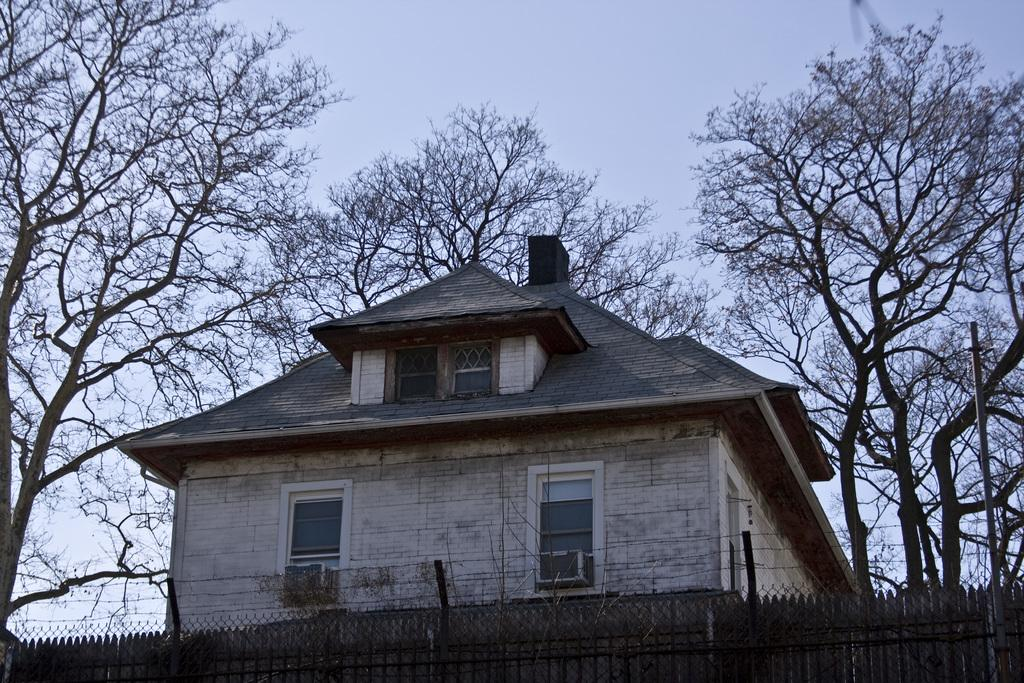What type of structure is visible in the image? There is a house in the image. What are the walls made of in the image? The walls are visible in the image. What type of windows are present in the house? There are glass windows in the image. What type of vegetation can be seen in the image? There are trees in the image. What is present at the bottom of the image? There is mesh and a fence at the bottom of the image. What can be seen in the background of the image? The sky is visible in the background of the image. What season is it in the image? The provided facts do not mention the season, so it cannot be determined from the image. 